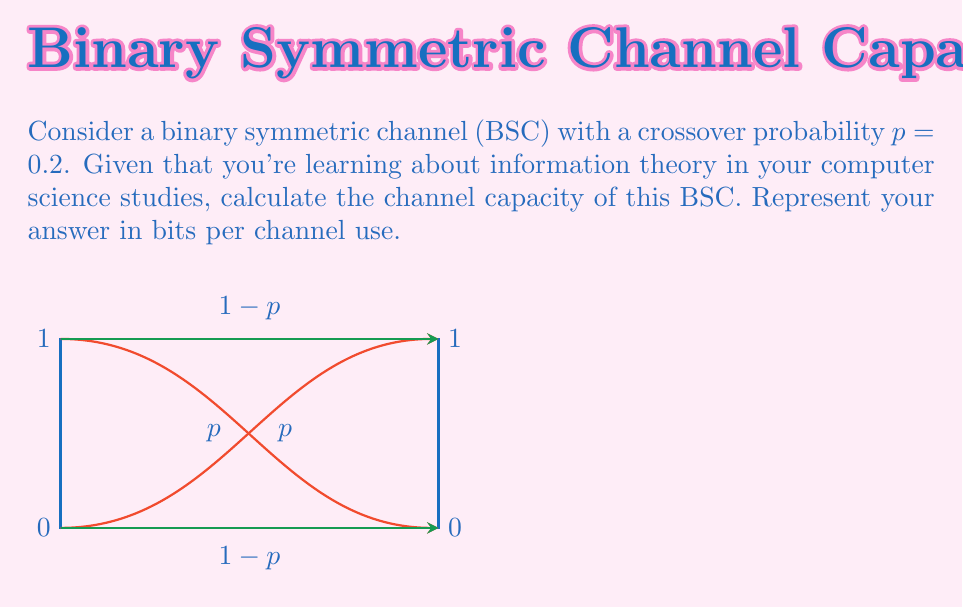Could you help me with this problem? To compute the channel capacity of a binary symmetric channel (BSC), we'll follow these steps:

1) The channel capacity $C$ for a BSC is given by:

   $$C = 1 - H(p)$$

   where $H(p)$ is the binary entropy function.

2) The binary entropy function is defined as:

   $$H(p) = -p \log_2(p) - (1-p) \log_2(1-p)$$

3) Given $p = 0.2$, let's calculate $H(p)$:

   $$H(0.2) = -0.2 \log_2(0.2) - 0.8 \log_2(0.8)$$

4) Calculate the logarithms:
   $\log_2(0.2) \approx -2.3219$
   $\log_2(0.8) \approx -0.3219$

5) Substitute these values:

   $$H(0.2) = -0.2 (-2.3219) - 0.8 (-0.3219)$$
   $$= 0.46438 + 0.25752 = 0.7219$$

6) Now we can calculate the channel capacity:

   $$C = 1 - H(0.2) = 1 - 0.7219 = 0.2781$$

Therefore, the channel capacity is approximately 0.2781 bits per channel use.
Answer: $0.2781$ bits/use 